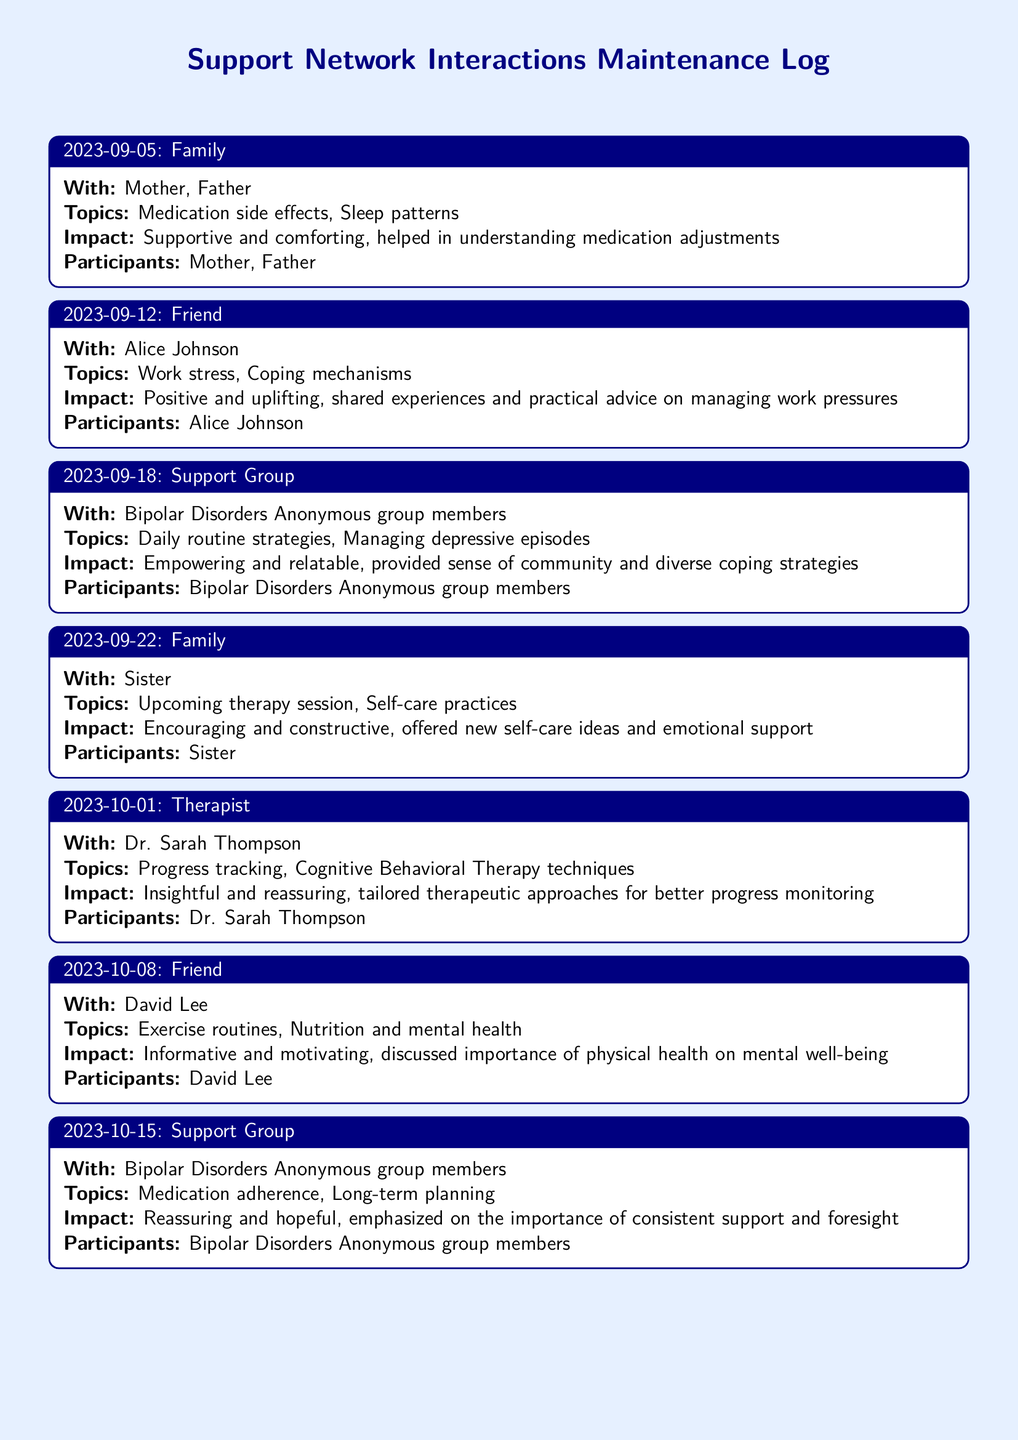What was discussed during the interaction on September 5, 2023? The topics discussed during this interaction included medication side effects and sleep patterns.
Answer: Medication side effects, Sleep patterns Who was the friend interacted with on October 8, 2023? The name of the friend for this interaction is mentioned directly in the document.
Answer: David Lee What emotional impact was reported from the support group interaction on October 15, 2023? The emotional impact specified for this interaction was reassuring and hopeful.
Answer: Reassuring and hopeful How many interactions were logged with family members? The number of interactions with family can be counted directly from the entries in the document.
Answer: 3 What coping mechanisms were discussed during the interaction with Alice Johnson? The specific topic discussed with Alice Johnson included coping mechanisms related to work stress.
Answer: Coping mechanisms Which participant was involved in the therapy session on October 1, 2023? The name of the participant involved in this therapy session can be found in the document.
Answer: Dr. Sarah Thompson What was the main focus of the interaction on September 18, 2023? The main focus of this support group interaction involves daily routine strategies and managing depressive episodes.
Answer: Daily routine strategies, Managing depressive episodes What key idea was shared in the interaction with the sister on September 22, 2023? The key idea discussed was related to upcoming therapy session and self-care practices.
Answer: Upcoming therapy session, Self-care practices 